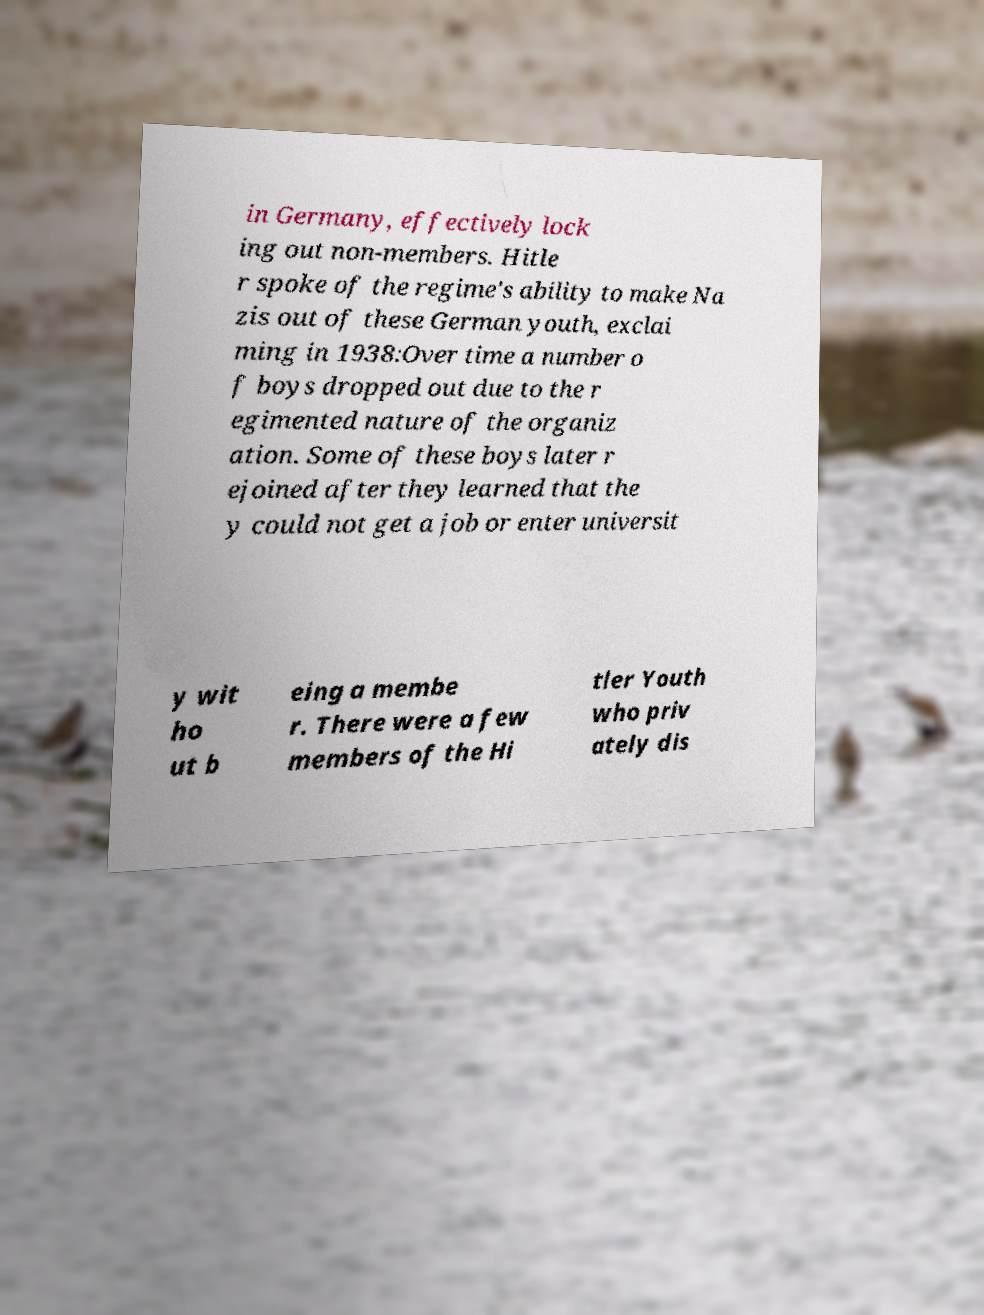Could you assist in decoding the text presented in this image and type it out clearly? in Germany, effectively lock ing out non-members. Hitle r spoke of the regime's ability to make Na zis out of these German youth, exclai ming in 1938:Over time a number o f boys dropped out due to the r egimented nature of the organiz ation. Some of these boys later r ejoined after they learned that the y could not get a job or enter universit y wit ho ut b eing a membe r. There were a few members of the Hi tler Youth who priv ately dis 